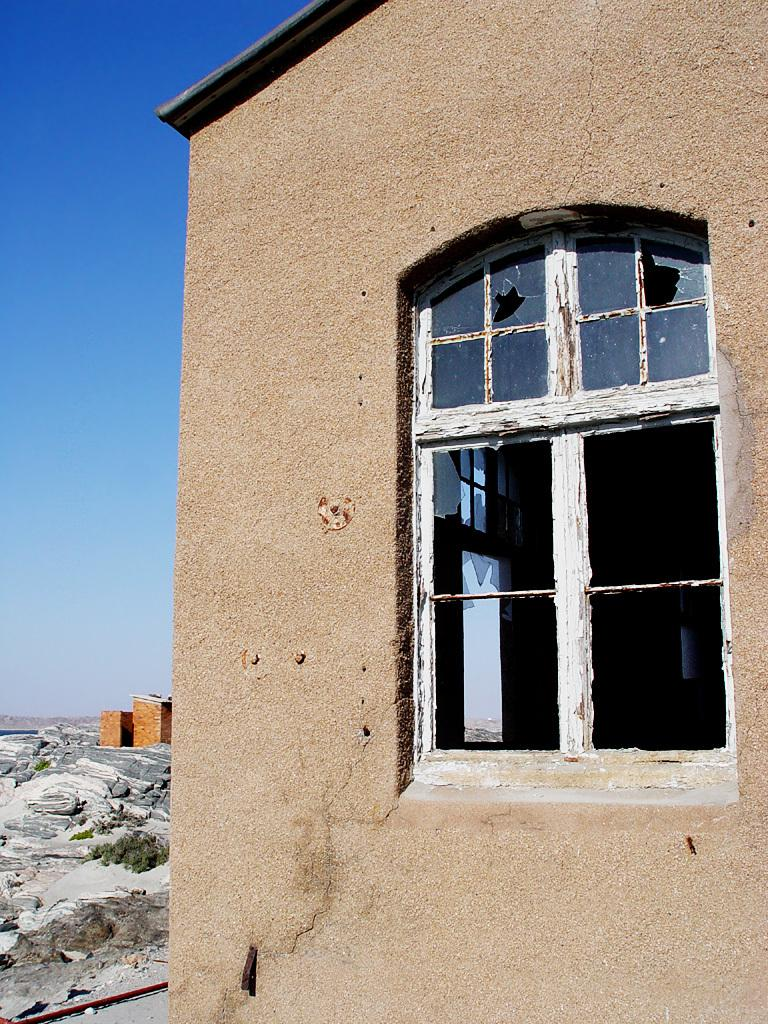What is the main subject of the image? The main subject of the image is a building. Can you describe the building in the image? The building has a window. What can be seen in the background of the image? Hills and plants are visible in the background. What part of the sky is visible in the image? The sky is visible on the left side of the image. What type of book is being read by the hospital in the image? There is no hospital or book present in the image; it features a building with a window and a background of hills and plants. 